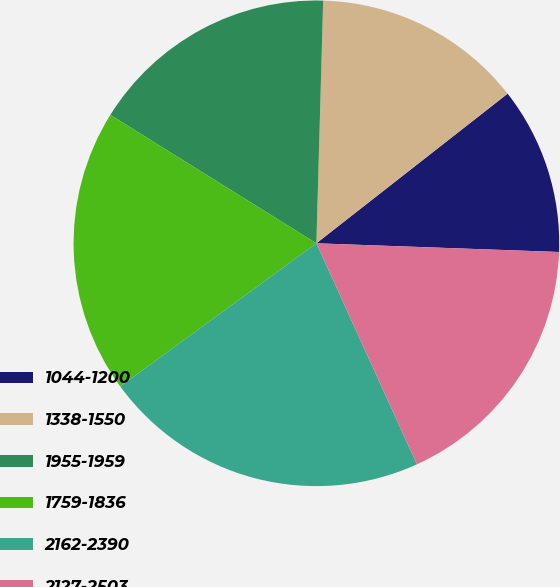Convert chart. <chart><loc_0><loc_0><loc_500><loc_500><pie_chart><fcel>1044-1200<fcel>1338-1550<fcel>1955-1959<fcel>1759-1836<fcel>2162-2390<fcel>2127-2503<nl><fcel>11.14%<fcel>13.99%<fcel>16.58%<fcel>18.91%<fcel>21.76%<fcel>17.64%<nl></chart> 